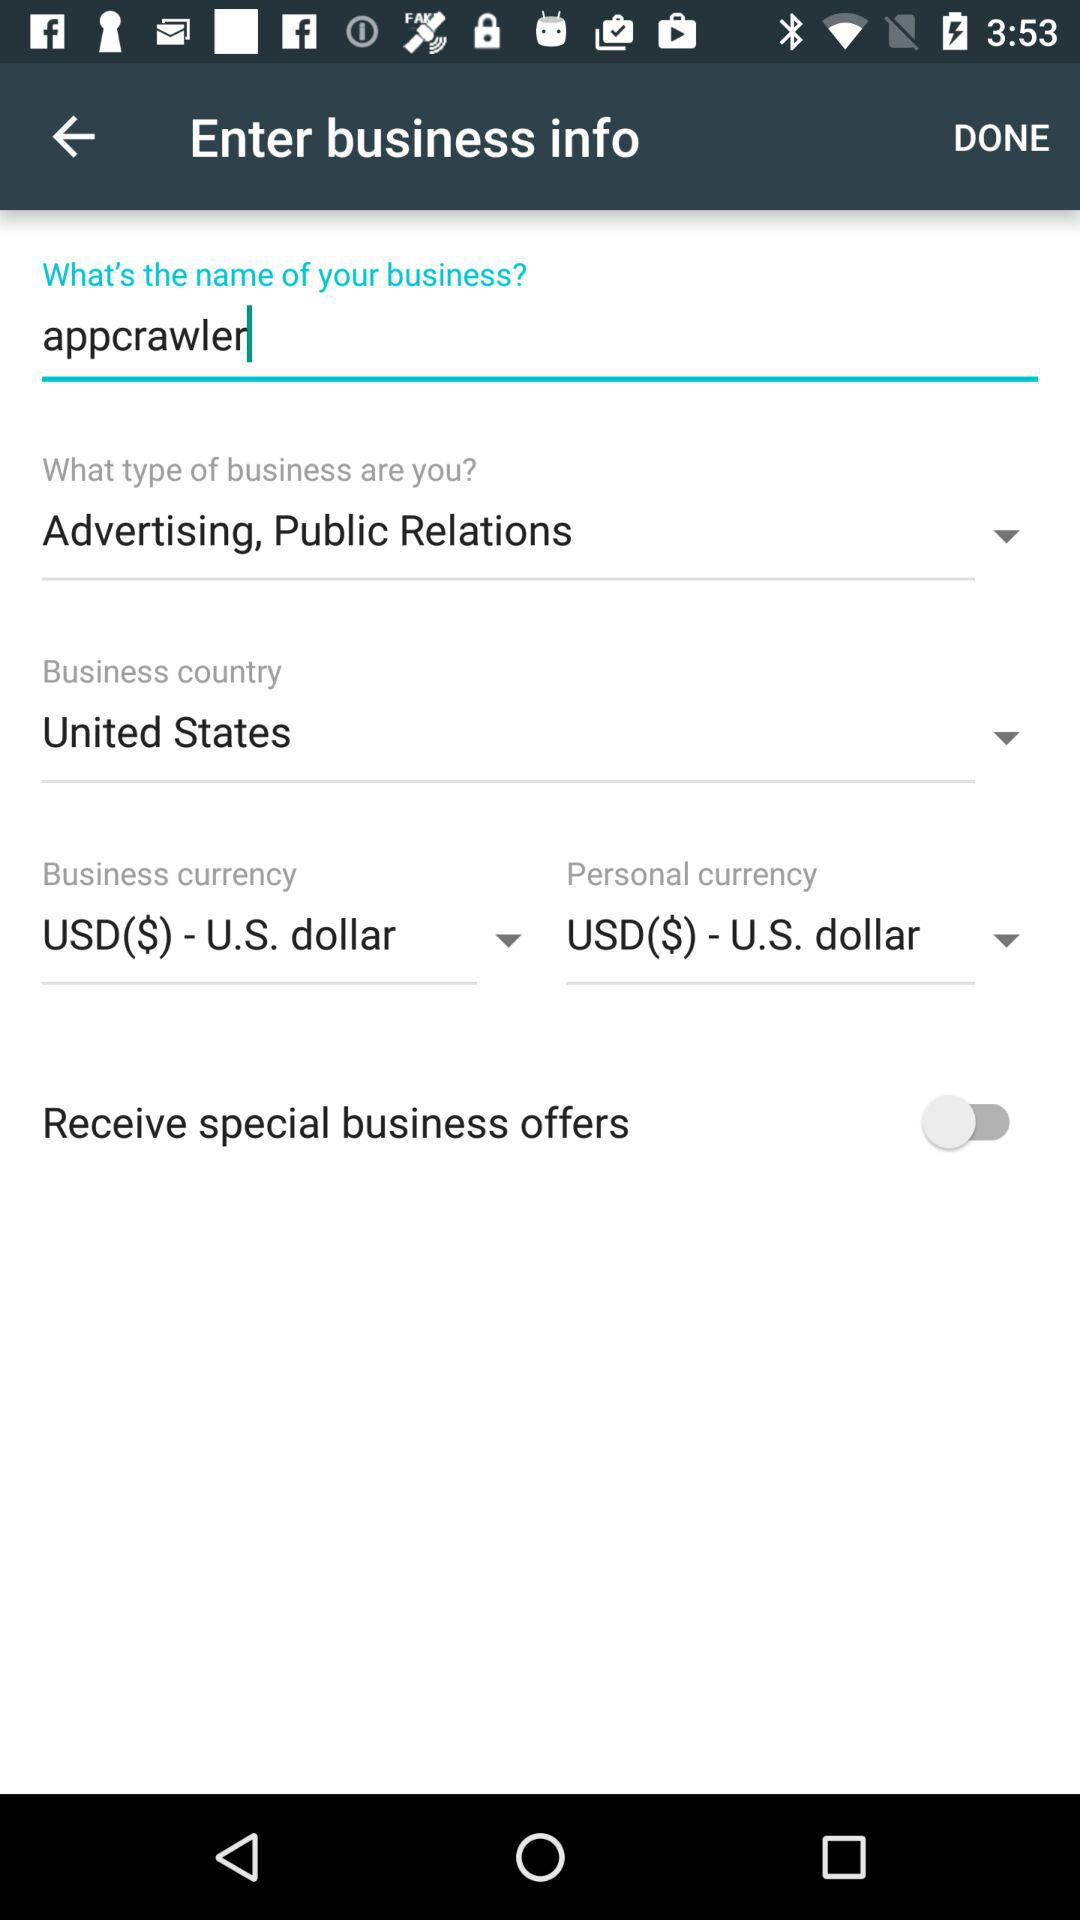What is the name of the business? The name of the business is "appcrawler". 